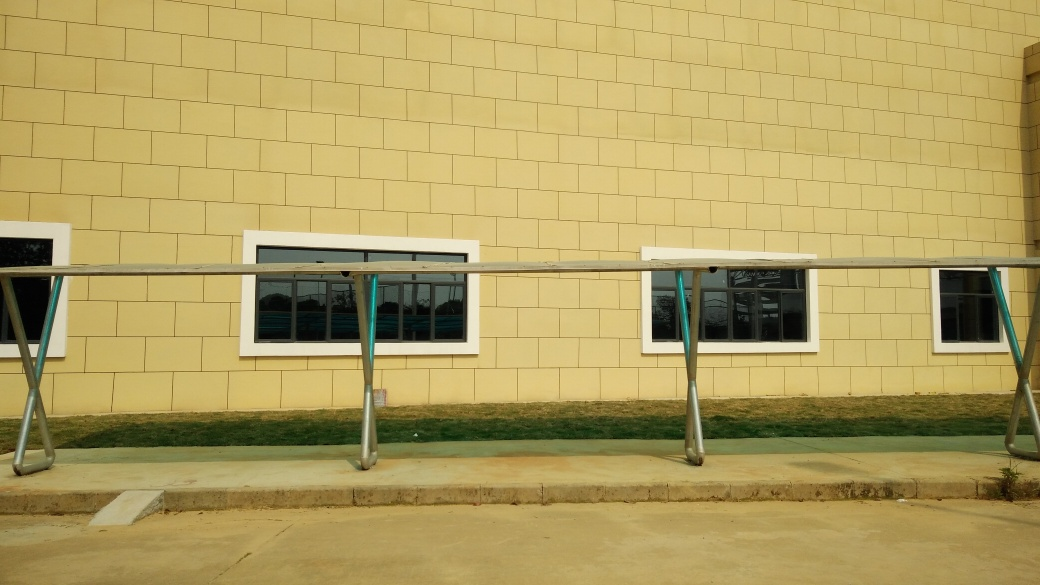What time of day does it appear to be in this image? Based on the lighting and shadows visible in the image, it seems to be taken during midday. The sun appears to be high, as indicated by the short shadows cast by the railing and the bright, even illumination on the building's facade. 